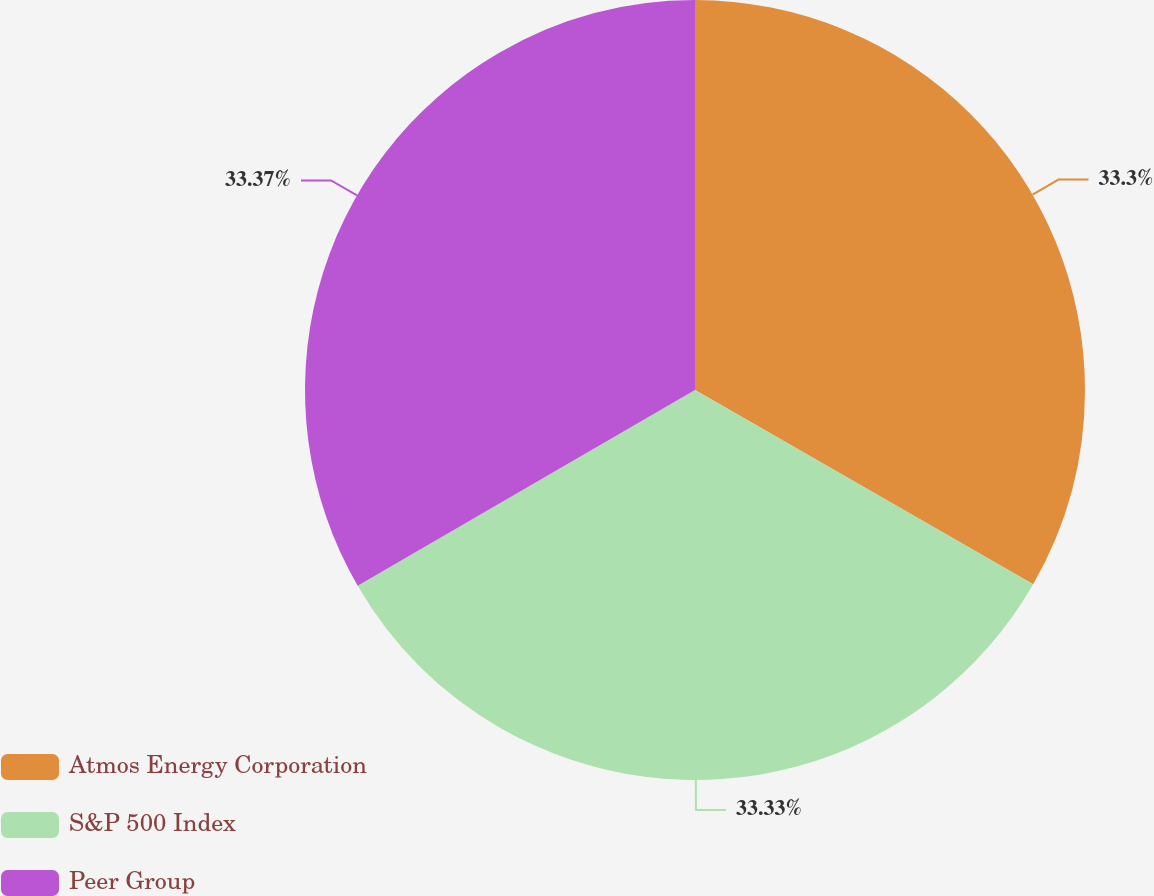Convert chart to OTSL. <chart><loc_0><loc_0><loc_500><loc_500><pie_chart><fcel>Atmos Energy Corporation<fcel>S&P 500 Index<fcel>Peer Group<nl><fcel>33.3%<fcel>33.33%<fcel>33.37%<nl></chart> 